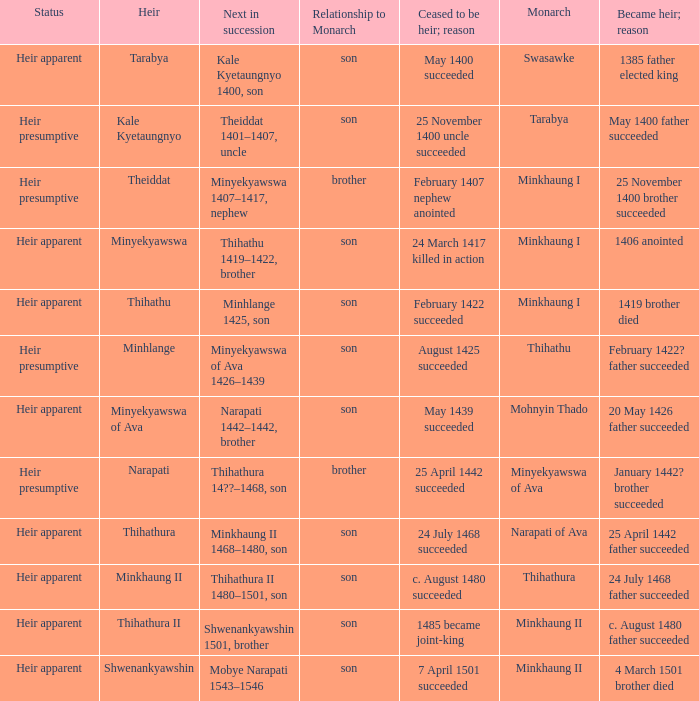How many reasons did the son and heir Kale Kyetaungnyo has when he ceased to be heir? 1.0. 